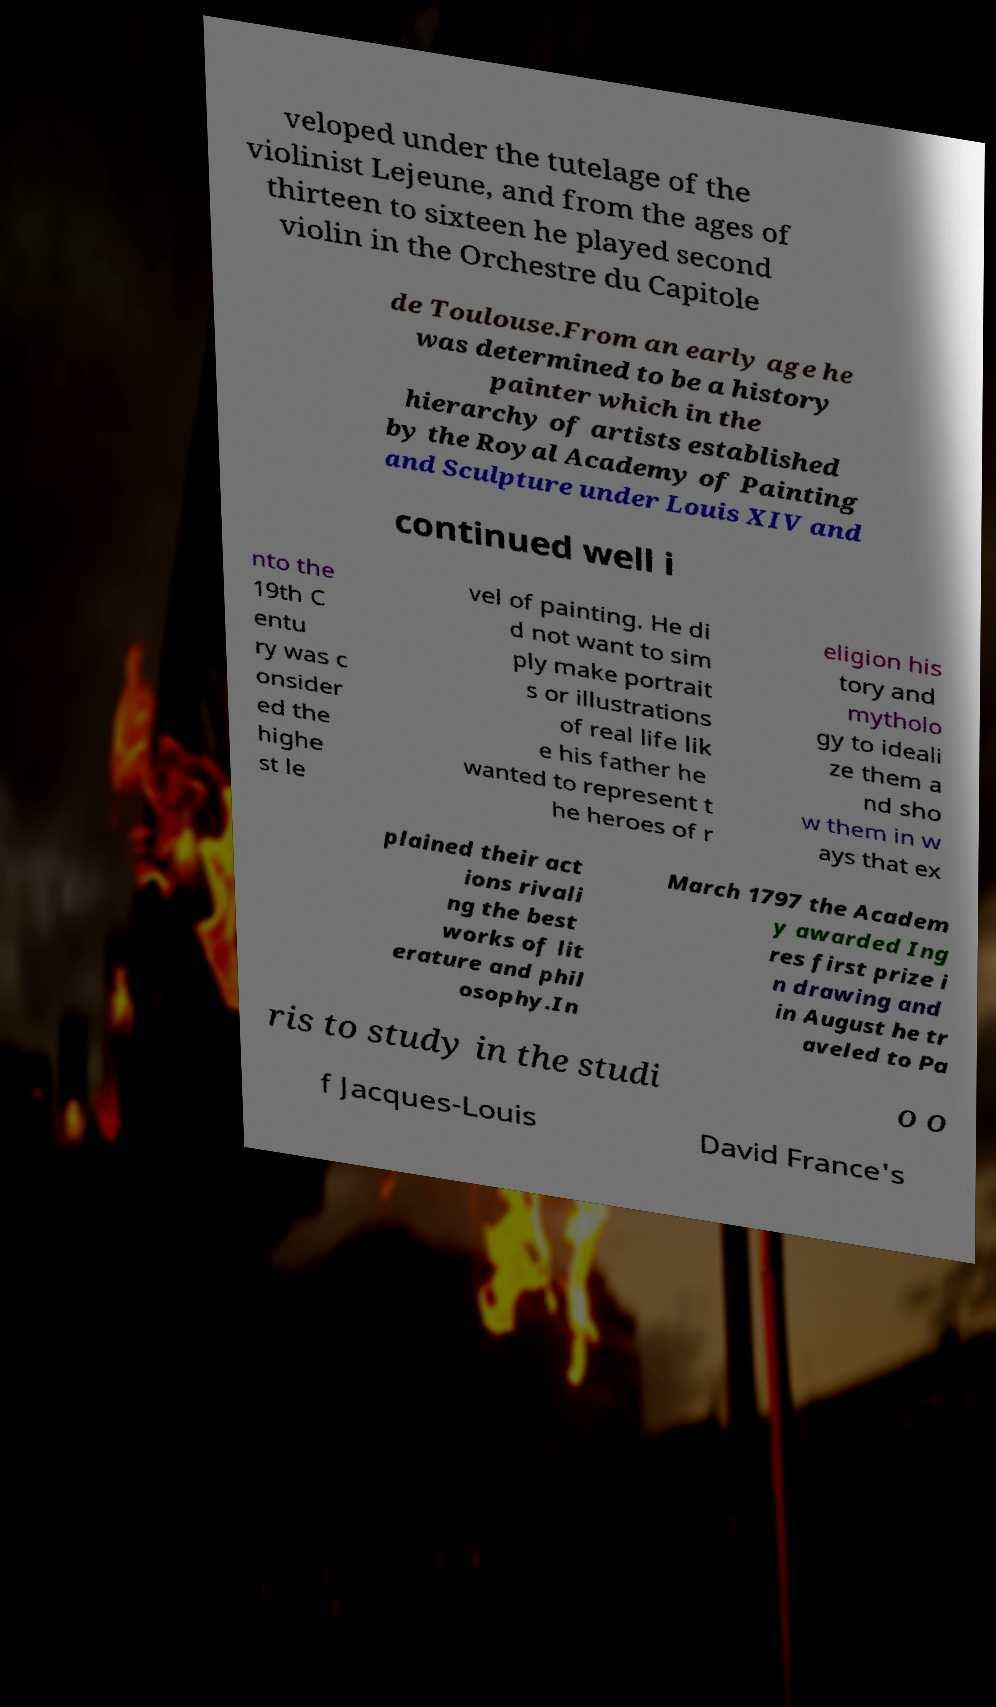Can you read and provide the text displayed in the image?This photo seems to have some interesting text. Can you extract and type it out for me? veloped under the tutelage of the violinist Lejeune, and from the ages of thirteen to sixteen he played second violin in the Orchestre du Capitole de Toulouse.From an early age he was determined to be a history painter which in the hierarchy of artists established by the Royal Academy of Painting and Sculpture under Louis XIV and continued well i nto the 19th C entu ry was c onsider ed the highe st le vel of painting. He di d not want to sim ply make portrait s or illustrations of real life lik e his father he wanted to represent t he heroes of r eligion his tory and mytholo gy to ideali ze them a nd sho w them in w ays that ex plained their act ions rivali ng the best works of lit erature and phil osophy.In March 1797 the Academ y awarded Ing res first prize i n drawing and in August he tr aveled to Pa ris to study in the studi o o f Jacques-Louis David France's 